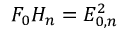Convert formula to latex. <formula><loc_0><loc_0><loc_500><loc_500>F _ { 0 } H _ { n } = E _ { 0 , n } ^ { 2 }</formula> 